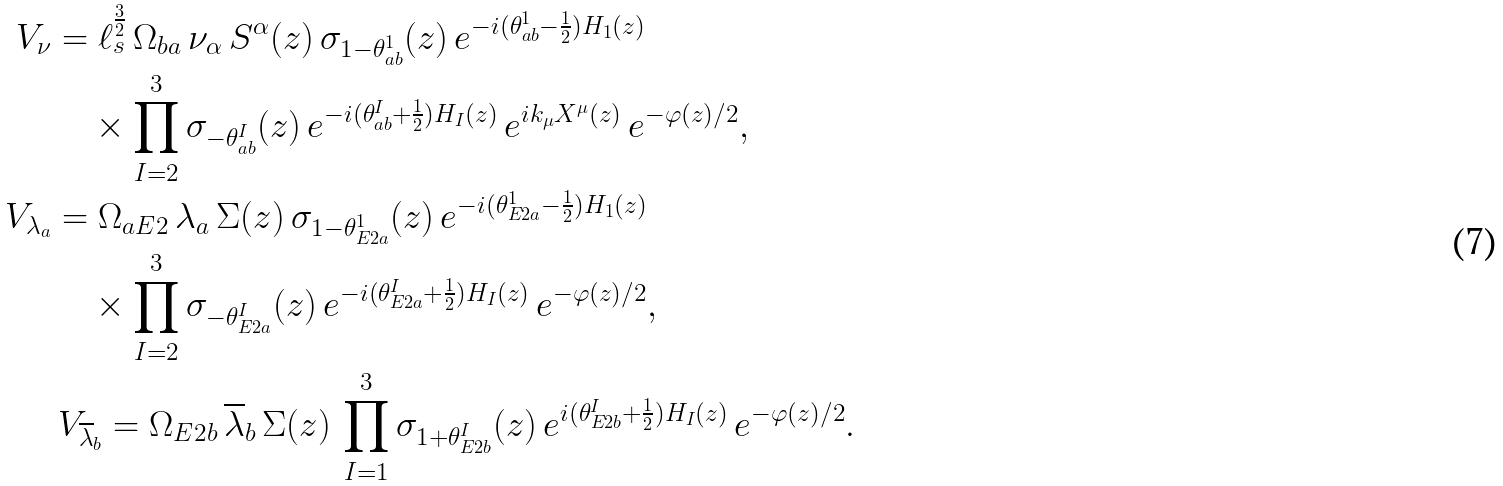Convert formula to latex. <formula><loc_0><loc_0><loc_500><loc_500>V _ { \nu } & = \ell _ { s } ^ { \frac { 3 } { 2 } } \, \Omega _ { b a } \, { \nu } _ { \alpha } \, S ^ { \alpha } ( z ) \, \sigma _ { 1 - \theta ^ { 1 } _ { a b } } ( z ) \, e ^ { - i ( \theta ^ { 1 } _ { a b } - \frac { 1 } { 2 } ) H _ { 1 } ( z ) } \quad \\ & \quad \times \prod _ { I = 2 } ^ { 3 } \sigma _ { - \theta ^ { I } _ { a b } } ( z ) \, e ^ { - i ( \theta ^ { I } _ { a b } + \frac { 1 } { 2 } ) H _ { I } ( z ) } \, e ^ { i k _ { \mu } X ^ { \mu } ( z ) } \, e ^ { - \varphi ( z ) / 2 } , \, \\ V _ { \lambda _ { a } } & = \Omega _ { a E 2 } \, \lambda _ { a } \, \Sigma ( z ) \, \sigma _ { 1 - \theta ^ { 1 } _ { E 2 a } } ( z ) \, e ^ { - i ( \theta ^ { 1 } _ { E 2 a } - \frac { 1 } { 2 } ) H _ { 1 } ( z ) } \quad \\ & \quad \times \prod _ { I = 2 } ^ { 3 } \sigma _ { - \theta ^ { I } _ { E 2 a } } ( z ) \, e ^ { - i ( \theta ^ { I } _ { E 2 a } + \frac { 1 } { 2 } ) H _ { I } ( z ) } \, e ^ { - \varphi ( z ) / 2 } , \\ & \, V _ { \overline { \lambda } _ { b } } = \Omega _ { E 2 b } \, \overline { \lambda } _ { b } \, \Sigma ( z ) \, \prod ^ { 3 } _ { I = 1 } \sigma _ { 1 + \theta ^ { I } _ { E 2 b } } ( z ) \, e ^ { i ( \theta ^ { I } _ { E 2 b } + \frac { 1 } { 2 } ) H _ { I } ( z ) } \, e ^ { - \varphi ( z ) / 2 } .</formula> 